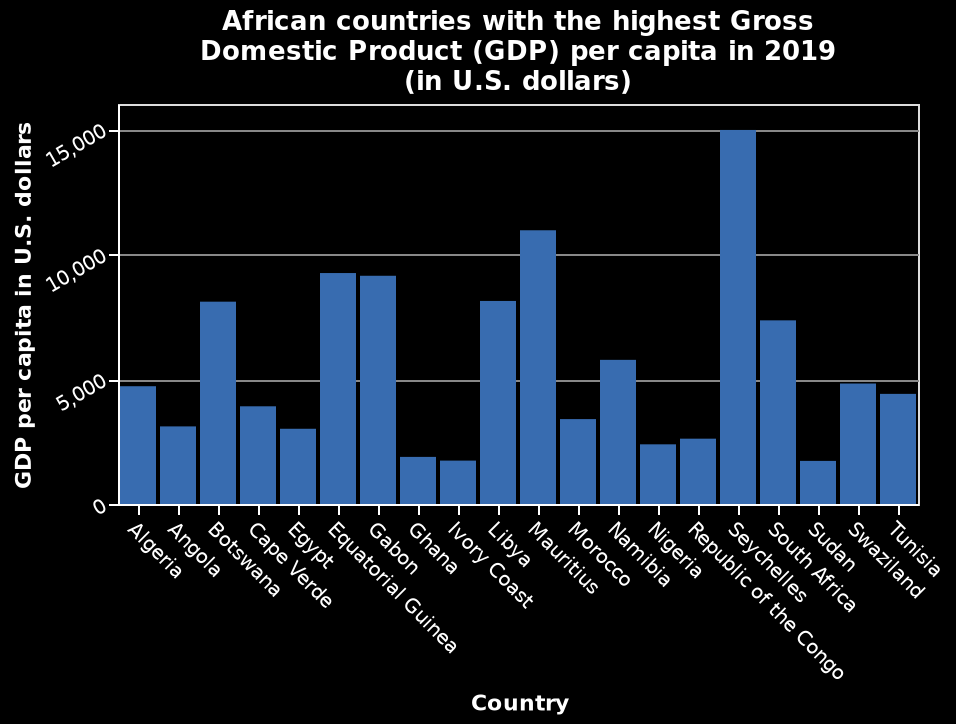<image>
Which country follows Seychelles in terms of GDP in 2019? Mauritius follows Seychelles in terms of GDP in 2019. Which African country had the lowest Gross Domestic Product (GDP) per capita in 2019?  The African country with the lowest GDP per capita in 2019 was Algeria. Offer a thorough analysis of the image. The Seychelles has the highest gdp by far in 2019,followed by Mauritius. please enumerates aspects of the construction of the chart Here a bar diagram is named African countries with the highest Gross Domestic Product (GDP) per capita in 2019 (in U.S. dollars). Country is plotted using a categorical scale with Algeria on one end and Tunisia at the other along the x-axis. GDP per capita in U.S. dollars is measured along a linear scale of range 0 to 15,000 on the y-axis. What is the country with the highest GDP in 2019?  The country with the highest GDP in 2019 is the Seychelles. 